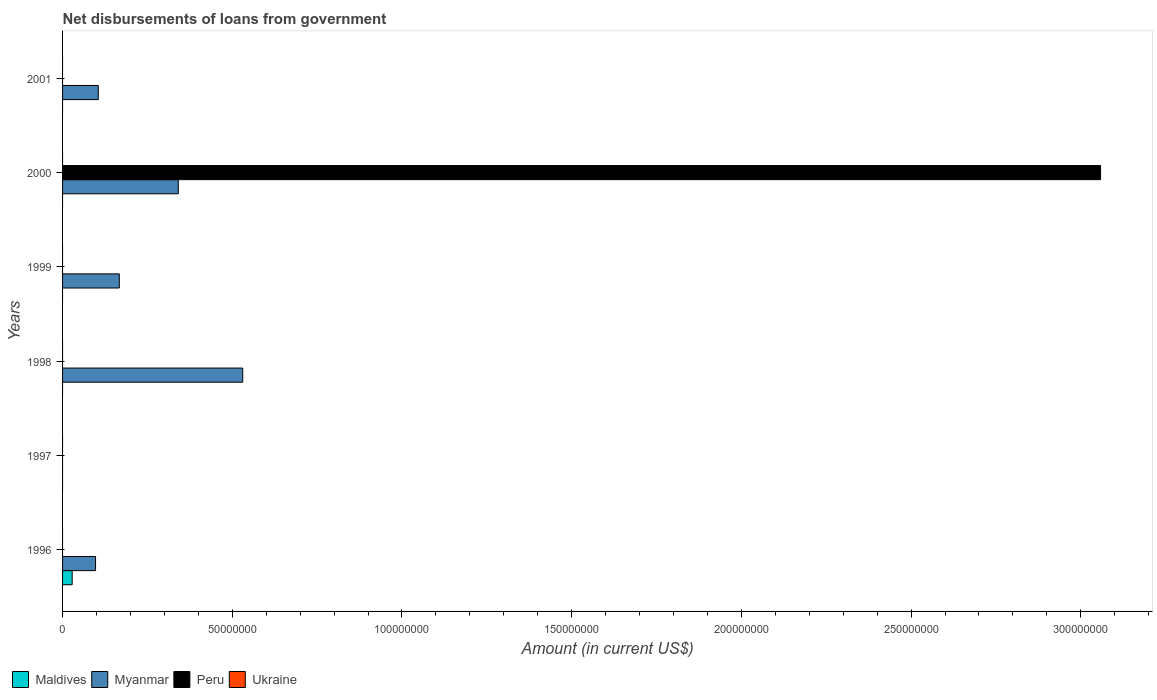How many different coloured bars are there?
Provide a short and direct response. 3. Are the number of bars per tick equal to the number of legend labels?
Your answer should be compact. No. What is the label of the 3rd group of bars from the top?
Provide a short and direct response. 1999. In how many cases, is the number of bars for a given year not equal to the number of legend labels?
Give a very brief answer. 6. Across all years, what is the maximum amount of loan disbursed from government in Peru?
Your answer should be very brief. 3.06e+08. In which year was the amount of loan disbursed from government in Myanmar maximum?
Keep it short and to the point. 1998. What is the difference between the amount of loan disbursed from government in Myanmar in 1998 and that in 2000?
Your response must be concise. 1.90e+07. What is the difference between the amount of loan disbursed from government in Peru in 2000 and the amount of loan disbursed from government in Ukraine in 2001?
Your answer should be compact. 3.06e+08. What is the average amount of loan disbursed from government in Maldives per year?
Keep it short and to the point. 4.72e+05. What is the difference between the highest and the second highest amount of loan disbursed from government in Myanmar?
Ensure brevity in your answer.  1.90e+07. What is the difference between the highest and the lowest amount of loan disbursed from government in Peru?
Your answer should be very brief. 3.06e+08. Is it the case that in every year, the sum of the amount of loan disbursed from government in Ukraine and amount of loan disbursed from government in Peru is greater than the amount of loan disbursed from government in Maldives?
Keep it short and to the point. No. How many bars are there?
Offer a terse response. 7. Are all the bars in the graph horizontal?
Provide a short and direct response. Yes. Are the values on the major ticks of X-axis written in scientific E-notation?
Make the answer very short. No. Does the graph contain grids?
Your answer should be compact. No. How many legend labels are there?
Make the answer very short. 4. What is the title of the graph?
Your response must be concise. Net disbursements of loans from government. Does "Pakistan" appear as one of the legend labels in the graph?
Ensure brevity in your answer.  No. What is the Amount (in current US$) of Maldives in 1996?
Keep it short and to the point. 2.83e+06. What is the Amount (in current US$) in Myanmar in 1996?
Make the answer very short. 9.72e+06. What is the Amount (in current US$) of Peru in 1996?
Offer a very short reply. 0. What is the Amount (in current US$) in Ukraine in 1996?
Make the answer very short. 0. What is the Amount (in current US$) of Myanmar in 1997?
Your answer should be very brief. 0. What is the Amount (in current US$) of Peru in 1997?
Provide a succinct answer. 0. What is the Amount (in current US$) in Maldives in 1998?
Make the answer very short. 0. What is the Amount (in current US$) in Myanmar in 1998?
Your response must be concise. 5.31e+07. What is the Amount (in current US$) of Myanmar in 1999?
Your answer should be compact. 1.67e+07. What is the Amount (in current US$) of Peru in 1999?
Ensure brevity in your answer.  0. What is the Amount (in current US$) of Ukraine in 1999?
Provide a succinct answer. 0. What is the Amount (in current US$) of Maldives in 2000?
Your response must be concise. 0. What is the Amount (in current US$) of Myanmar in 2000?
Offer a terse response. 3.41e+07. What is the Amount (in current US$) of Peru in 2000?
Offer a terse response. 3.06e+08. What is the Amount (in current US$) in Ukraine in 2000?
Give a very brief answer. 0. What is the Amount (in current US$) in Maldives in 2001?
Provide a succinct answer. 0. What is the Amount (in current US$) in Myanmar in 2001?
Ensure brevity in your answer.  1.05e+07. What is the Amount (in current US$) in Ukraine in 2001?
Make the answer very short. 0. Across all years, what is the maximum Amount (in current US$) in Maldives?
Make the answer very short. 2.83e+06. Across all years, what is the maximum Amount (in current US$) in Myanmar?
Keep it short and to the point. 5.31e+07. Across all years, what is the maximum Amount (in current US$) of Peru?
Your answer should be compact. 3.06e+08. Across all years, what is the minimum Amount (in current US$) of Myanmar?
Provide a short and direct response. 0. What is the total Amount (in current US$) of Maldives in the graph?
Your answer should be compact. 2.83e+06. What is the total Amount (in current US$) of Myanmar in the graph?
Make the answer very short. 1.24e+08. What is the total Amount (in current US$) in Peru in the graph?
Offer a terse response. 3.06e+08. What is the difference between the Amount (in current US$) in Myanmar in 1996 and that in 1998?
Provide a succinct answer. -4.34e+07. What is the difference between the Amount (in current US$) in Myanmar in 1996 and that in 1999?
Offer a very short reply. -7.00e+06. What is the difference between the Amount (in current US$) of Myanmar in 1996 and that in 2000?
Give a very brief answer. -2.44e+07. What is the difference between the Amount (in current US$) of Myanmar in 1996 and that in 2001?
Provide a succinct answer. -8.08e+05. What is the difference between the Amount (in current US$) in Myanmar in 1998 and that in 1999?
Your answer should be very brief. 3.64e+07. What is the difference between the Amount (in current US$) in Myanmar in 1998 and that in 2000?
Your response must be concise. 1.90e+07. What is the difference between the Amount (in current US$) of Myanmar in 1998 and that in 2001?
Keep it short and to the point. 4.26e+07. What is the difference between the Amount (in current US$) in Myanmar in 1999 and that in 2000?
Your answer should be very brief. -1.74e+07. What is the difference between the Amount (in current US$) in Myanmar in 1999 and that in 2001?
Your answer should be very brief. 6.19e+06. What is the difference between the Amount (in current US$) in Myanmar in 2000 and that in 2001?
Provide a succinct answer. 2.36e+07. What is the difference between the Amount (in current US$) of Maldives in 1996 and the Amount (in current US$) of Myanmar in 1998?
Offer a terse response. -5.02e+07. What is the difference between the Amount (in current US$) in Maldives in 1996 and the Amount (in current US$) in Myanmar in 1999?
Your answer should be compact. -1.39e+07. What is the difference between the Amount (in current US$) in Maldives in 1996 and the Amount (in current US$) in Myanmar in 2000?
Your answer should be compact. -3.13e+07. What is the difference between the Amount (in current US$) in Maldives in 1996 and the Amount (in current US$) in Peru in 2000?
Your answer should be very brief. -3.03e+08. What is the difference between the Amount (in current US$) in Myanmar in 1996 and the Amount (in current US$) in Peru in 2000?
Your answer should be compact. -2.96e+08. What is the difference between the Amount (in current US$) of Maldives in 1996 and the Amount (in current US$) of Myanmar in 2001?
Keep it short and to the point. -7.69e+06. What is the difference between the Amount (in current US$) in Myanmar in 1998 and the Amount (in current US$) in Peru in 2000?
Give a very brief answer. -2.53e+08. What is the difference between the Amount (in current US$) of Myanmar in 1999 and the Amount (in current US$) of Peru in 2000?
Offer a very short reply. -2.89e+08. What is the average Amount (in current US$) of Maldives per year?
Offer a terse response. 4.72e+05. What is the average Amount (in current US$) in Myanmar per year?
Give a very brief answer. 2.07e+07. What is the average Amount (in current US$) of Peru per year?
Provide a short and direct response. 5.10e+07. What is the average Amount (in current US$) of Ukraine per year?
Your response must be concise. 0. In the year 1996, what is the difference between the Amount (in current US$) of Maldives and Amount (in current US$) of Myanmar?
Provide a short and direct response. -6.89e+06. In the year 2000, what is the difference between the Amount (in current US$) in Myanmar and Amount (in current US$) in Peru?
Offer a terse response. -2.72e+08. What is the ratio of the Amount (in current US$) of Myanmar in 1996 to that in 1998?
Give a very brief answer. 0.18. What is the ratio of the Amount (in current US$) of Myanmar in 1996 to that in 1999?
Keep it short and to the point. 0.58. What is the ratio of the Amount (in current US$) in Myanmar in 1996 to that in 2000?
Provide a succinct answer. 0.28. What is the ratio of the Amount (in current US$) of Myanmar in 1996 to that in 2001?
Keep it short and to the point. 0.92. What is the ratio of the Amount (in current US$) of Myanmar in 1998 to that in 1999?
Ensure brevity in your answer.  3.18. What is the ratio of the Amount (in current US$) in Myanmar in 1998 to that in 2000?
Offer a very short reply. 1.56. What is the ratio of the Amount (in current US$) in Myanmar in 1998 to that in 2001?
Make the answer very short. 5.04. What is the ratio of the Amount (in current US$) of Myanmar in 1999 to that in 2000?
Your answer should be compact. 0.49. What is the ratio of the Amount (in current US$) in Myanmar in 1999 to that in 2001?
Provide a succinct answer. 1.59. What is the ratio of the Amount (in current US$) in Myanmar in 2000 to that in 2001?
Your answer should be very brief. 3.24. What is the difference between the highest and the second highest Amount (in current US$) of Myanmar?
Make the answer very short. 1.90e+07. What is the difference between the highest and the lowest Amount (in current US$) in Maldives?
Offer a very short reply. 2.83e+06. What is the difference between the highest and the lowest Amount (in current US$) of Myanmar?
Keep it short and to the point. 5.31e+07. What is the difference between the highest and the lowest Amount (in current US$) of Peru?
Offer a terse response. 3.06e+08. 